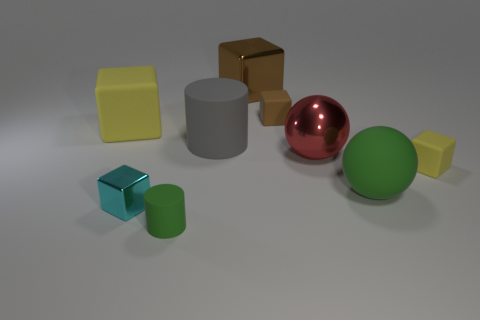Subtract all tiny metallic cubes. How many cubes are left? 4 Add 1 gray things. How many objects exist? 10 Subtract all cylinders. How many objects are left? 7 Subtract all green cylinders. How many cylinders are left? 1 Subtract all brown blocks. How many green spheres are left? 1 Subtract all big purple objects. Subtract all large blocks. How many objects are left? 7 Add 4 brown rubber cubes. How many brown rubber cubes are left? 5 Add 1 purple rubber objects. How many purple rubber objects exist? 1 Subtract 1 green cylinders. How many objects are left? 8 Subtract all cyan cylinders. Subtract all purple cubes. How many cylinders are left? 2 